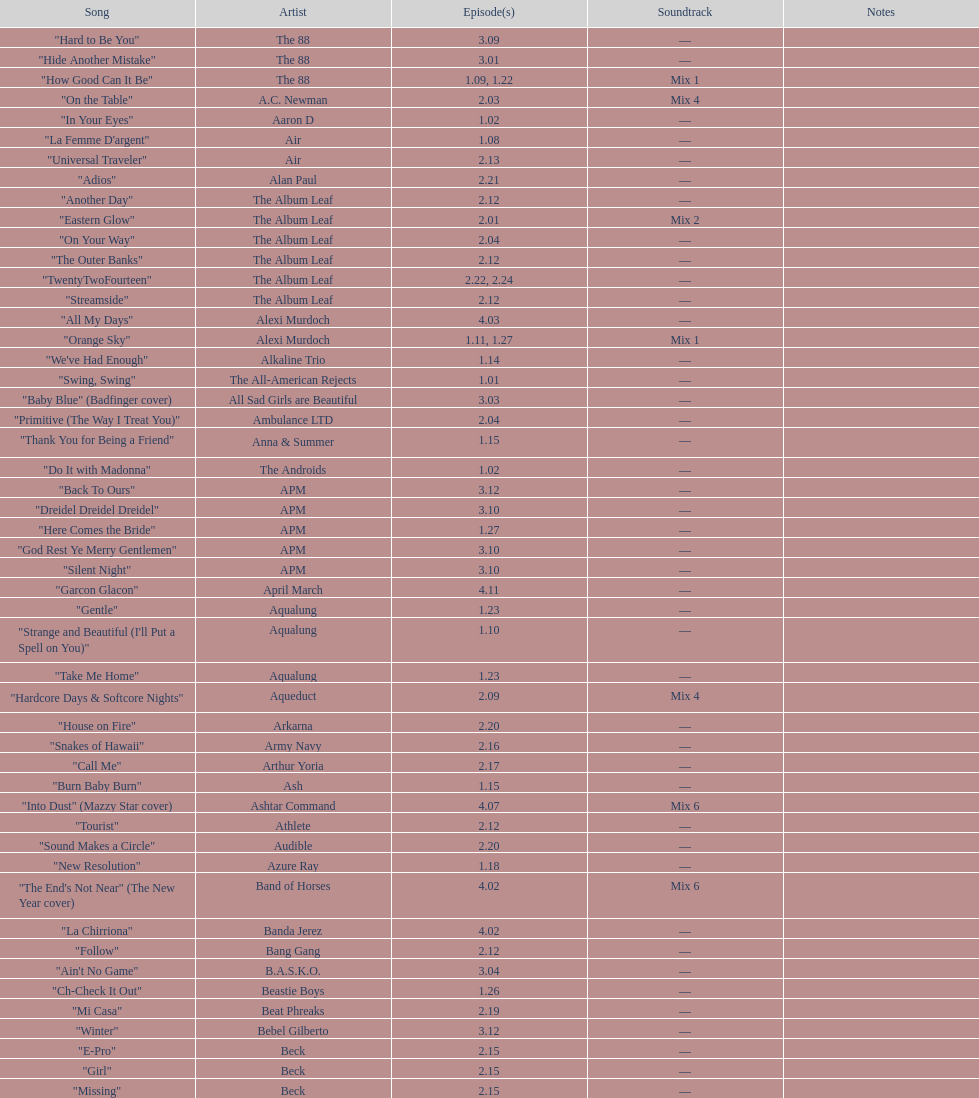"girl" and "el pro" were performed by which artist? Beck. 